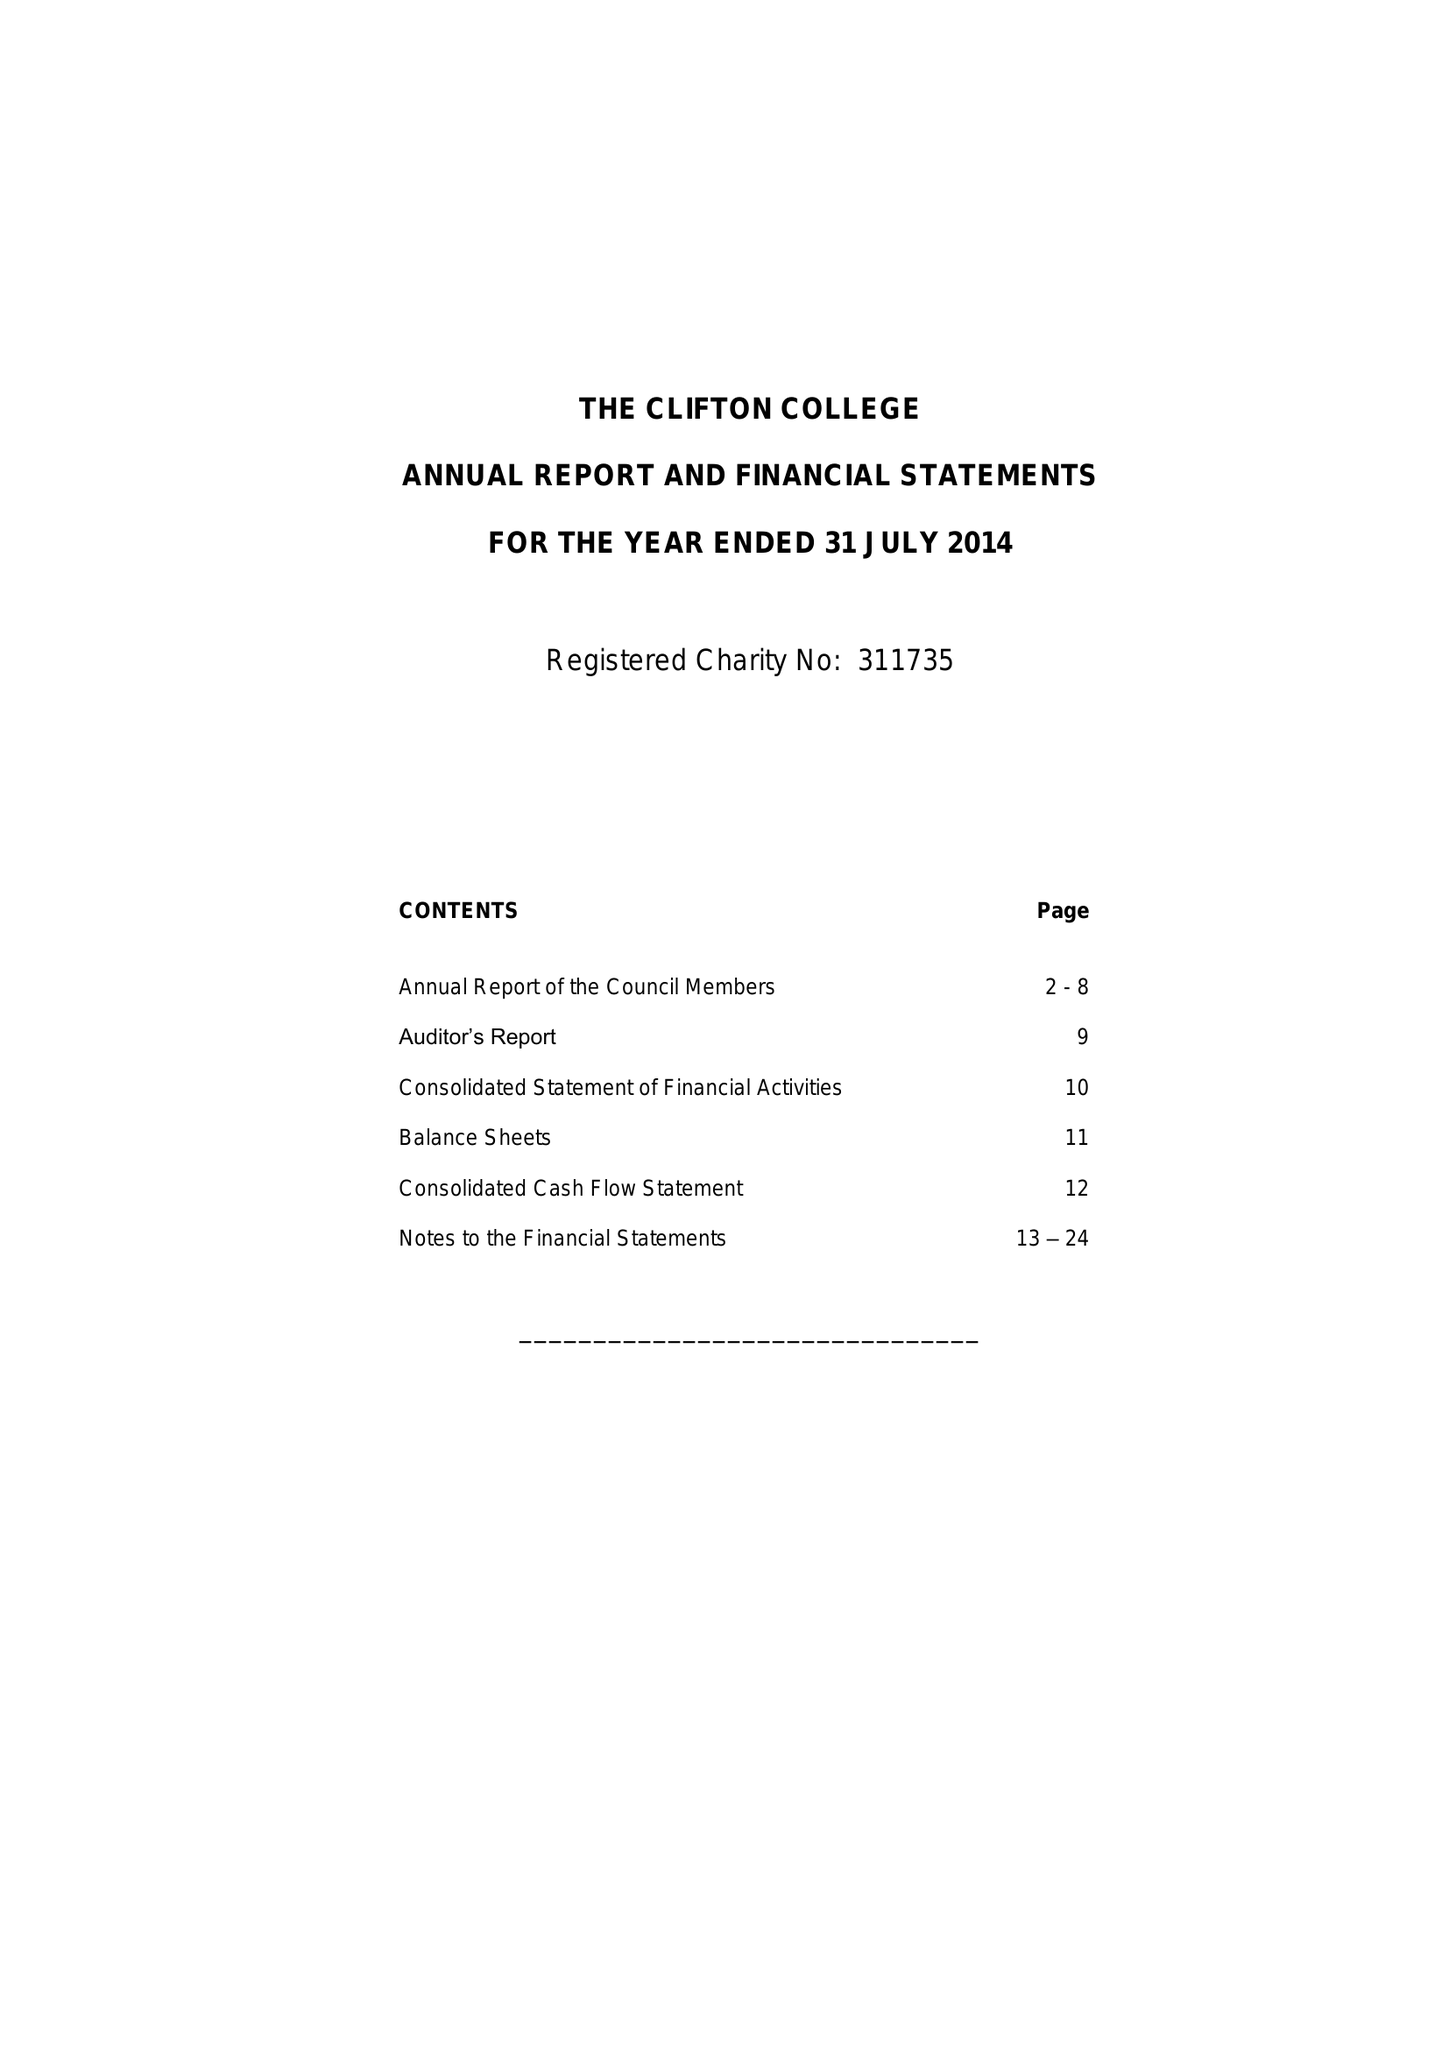What is the value for the spending_annually_in_british_pounds?
Answer the question using a single word or phrase. 26968000.00 